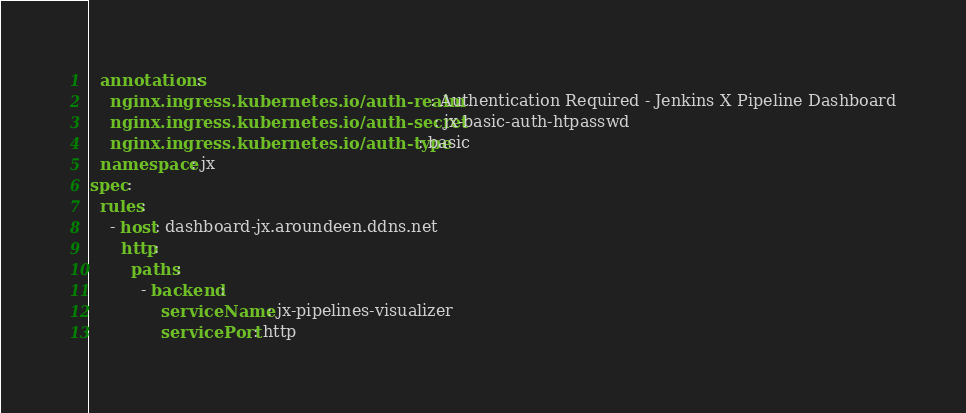<code> <loc_0><loc_0><loc_500><loc_500><_YAML_>  annotations:
    nginx.ingress.kubernetes.io/auth-realm: Authentication Required - Jenkins X Pipeline Dashboard
    nginx.ingress.kubernetes.io/auth-secret: jx-basic-auth-htpasswd
    nginx.ingress.kubernetes.io/auth-type: basic
  namespace: jx
spec:
  rules:
    - host: dashboard-jx.aroundeen.ddns.net
      http:
        paths:
          - backend:
              serviceName: jx-pipelines-visualizer
              servicePort: http
</code> 